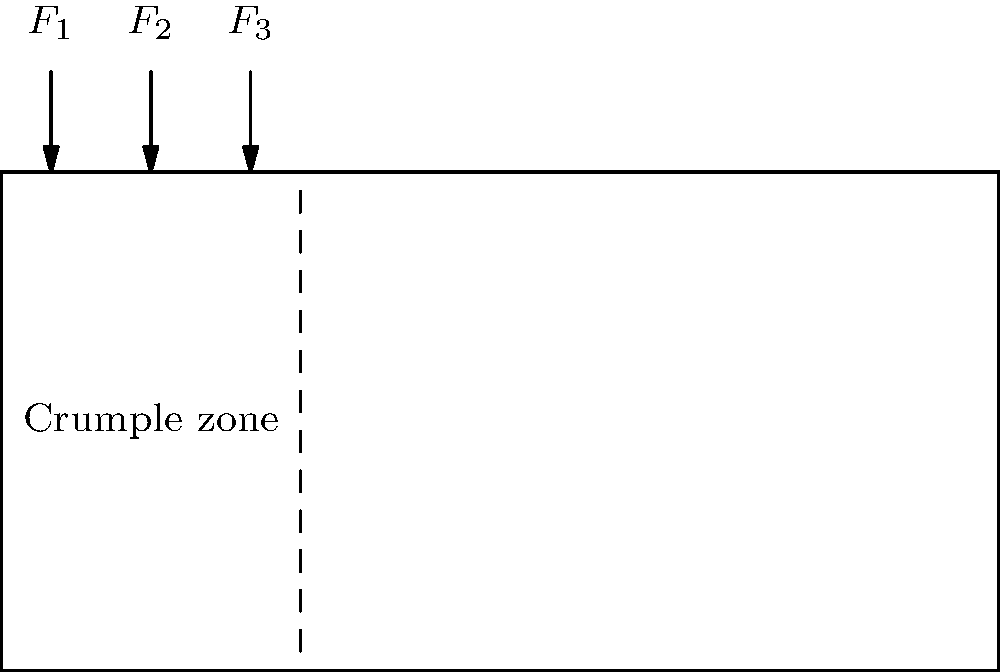In a car's crumple zone during a collision, three forces ($F_1$, $F_2$, and $F_3$) are distributed as shown in the diagram. If the total force applied to the crumple zone is 60 kN and $F_2$ is twice as large as $F_1$ and $F_3$, calculate the magnitude of $F_2$. How does this force distribution contribute to passenger safety? To solve this problem, we'll follow these steps:

1. Define the relationship between forces:
   $F_2 = 2F_1$ and $F_2 = 2F_3$

2. Express the total force equation:
   $F_{total} = F_1 + F_2 + F_3 = 60$ kN

3. Substitute the relationships into the total force equation:
   $F_1 + 2F_1 + F_1 = 60$ kN
   $4F_1 = 60$ kN

4. Solve for $F_1$:
   $F_1 = 60 / 4 = 15$ kN

5. Calculate $F_2$:
   $F_2 = 2F_1 = 2 * 15 = 30$ kN

The force distribution contributes to passenger safety by:
a) Absorbing and dissipating collision energy through controlled deformation
b) Reducing the peak force transmitted to the passenger compartment
c) Extending the duration of impact, lowering the overall deceleration experienced by occupants
d) Directing forces away from the passenger compartment, maintaining its integrity

This design aligns with the concept of a "safety cell" around the occupants, which is crucial for minimizing injuries in traffic accidents.
Answer: $F_2 = 30$ kN; Crumple zone absorbs energy, reduces peak force, extends impact duration, and directs forces away from passengers. 